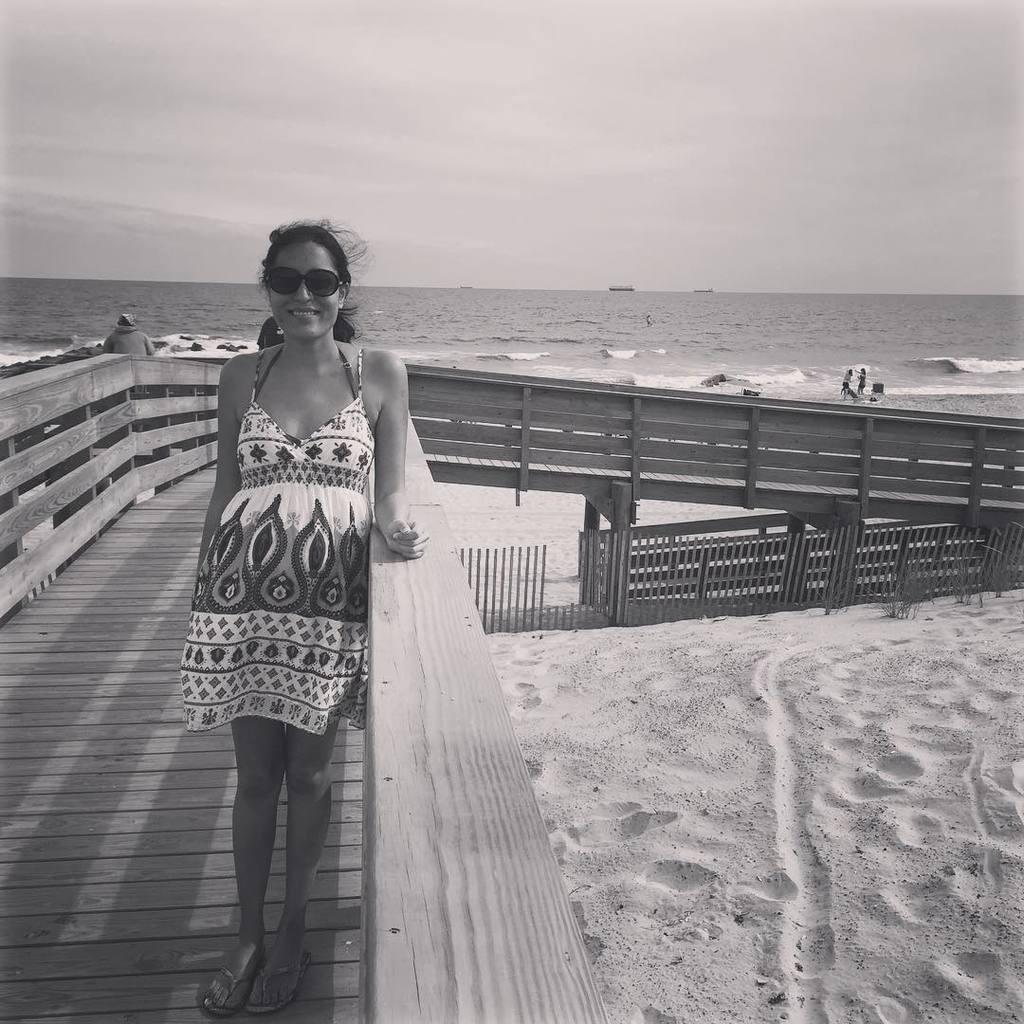Could you give a brief overview of what you see in this image? In this image we can see a few people, a lady is standing on the wooden path, also we can see the sky, and the ocean. 